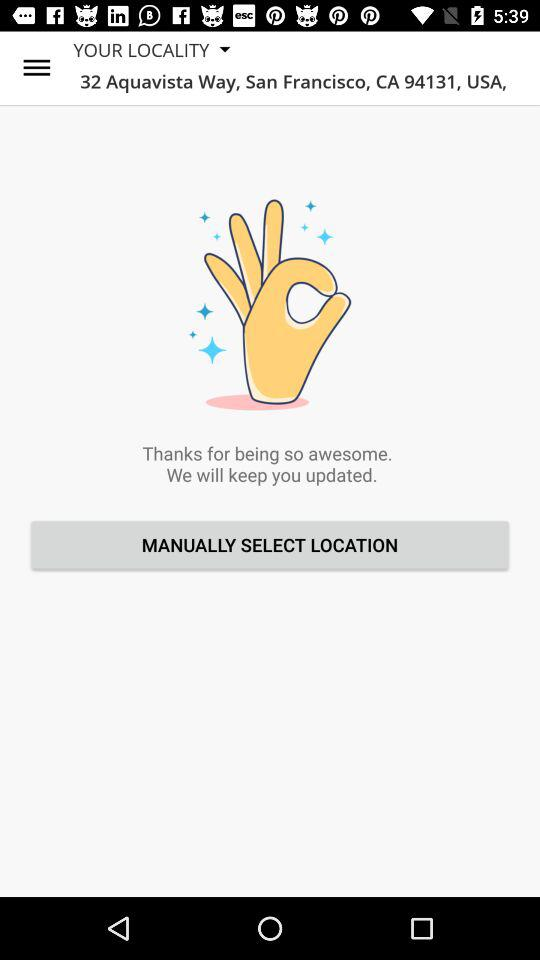What is the address? The address is 32 Aquavista Way, San Francisco, CA 94131, USA. 